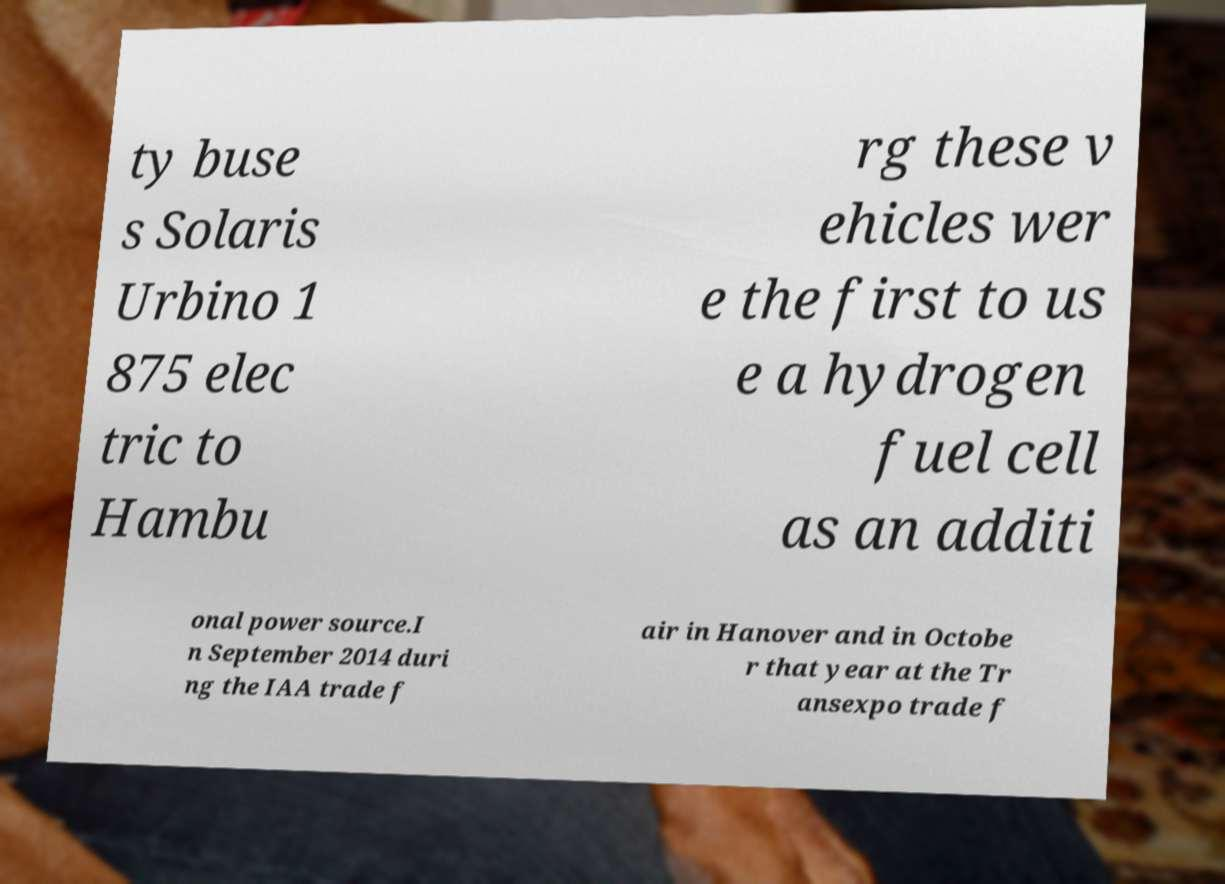Please read and relay the text visible in this image. What does it say? ty buse s Solaris Urbino 1 875 elec tric to Hambu rg these v ehicles wer e the first to us e a hydrogen fuel cell as an additi onal power source.I n September 2014 duri ng the IAA trade f air in Hanover and in Octobe r that year at the Tr ansexpo trade f 